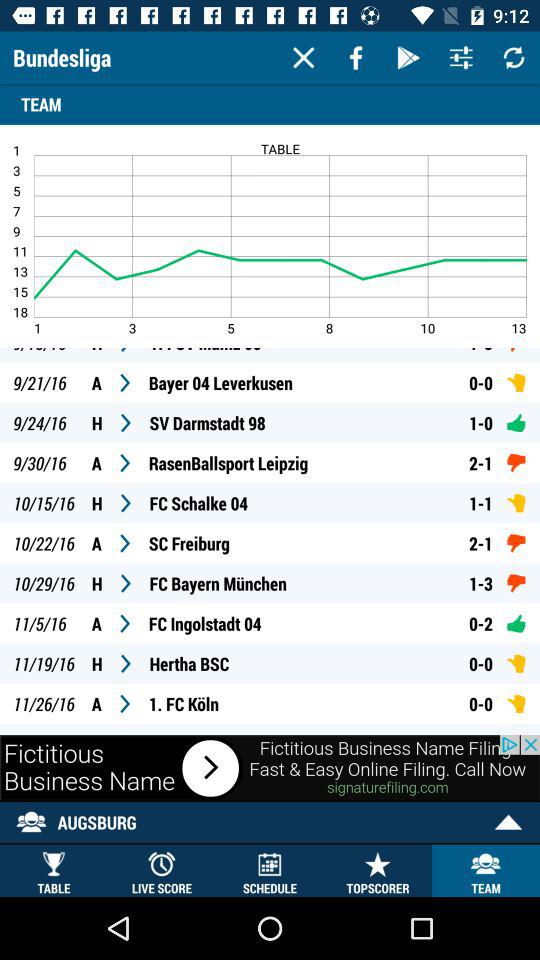What is the selected tab? The selected tab is "TABLE". 